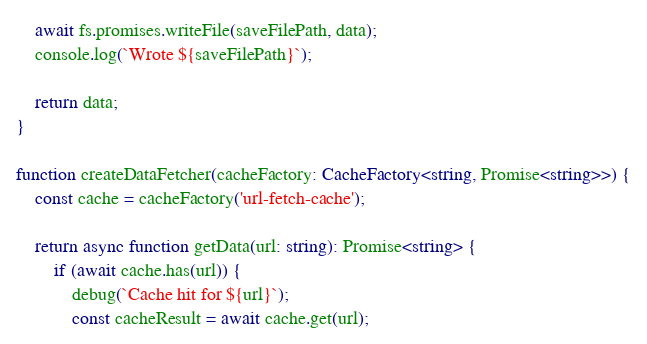<code> <loc_0><loc_0><loc_500><loc_500><_TypeScript_>    await fs.promises.writeFile(saveFilePath, data);
    console.log(`Wrote ${saveFilePath}`);

    return data;
}

function createDataFetcher(cacheFactory: CacheFactory<string, Promise<string>>) {
    const cache = cacheFactory('url-fetch-cache');

    return async function getData(url: string): Promise<string> {
        if (await cache.has(url)) {
            debug(`Cache hit for ${url}`);
            const cacheResult = await cache.get(url);</code> 